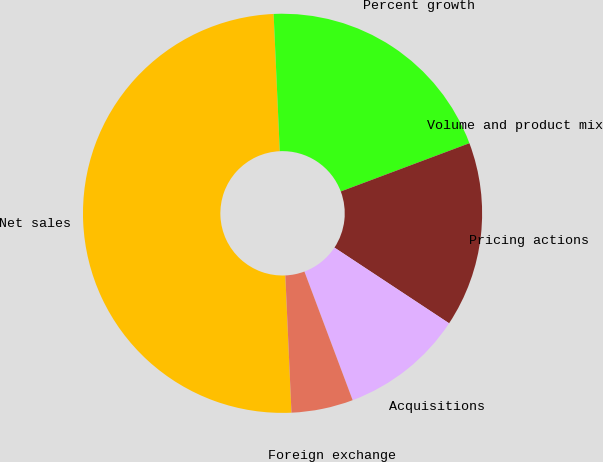Convert chart. <chart><loc_0><loc_0><loc_500><loc_500><pie_chart><fcel>Net sales<fcel>Percent growth<fcel>Volume and product mix<fcel>Pricing actions<fcel>Acquisitions<fcel>Foreign exchange<nl><fcel>50.0%<fcel>20.0%<fcel>0.0%<fcel>15.0%<fcel>10.0%<fcel>5.0%<nl></chart> 